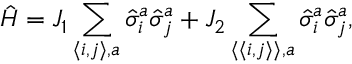<formula> <loc_0><loc_0><loc_500><loc_500>\hat { H } = J _ { 1 } \sum _ { \langle i , j \rangle , a } \hat { \sigma } _ { i } ^ { a } \hat { \sigma } _ { j } ^ { a } + J _ { 2 } \sum _ { { \langle \langle } i , j { \rangle \rangle } , a } \hat { \sigma } _ { i } ^ { a } \hat { \sigma } _ { j } ^ { a } ,</formula> 